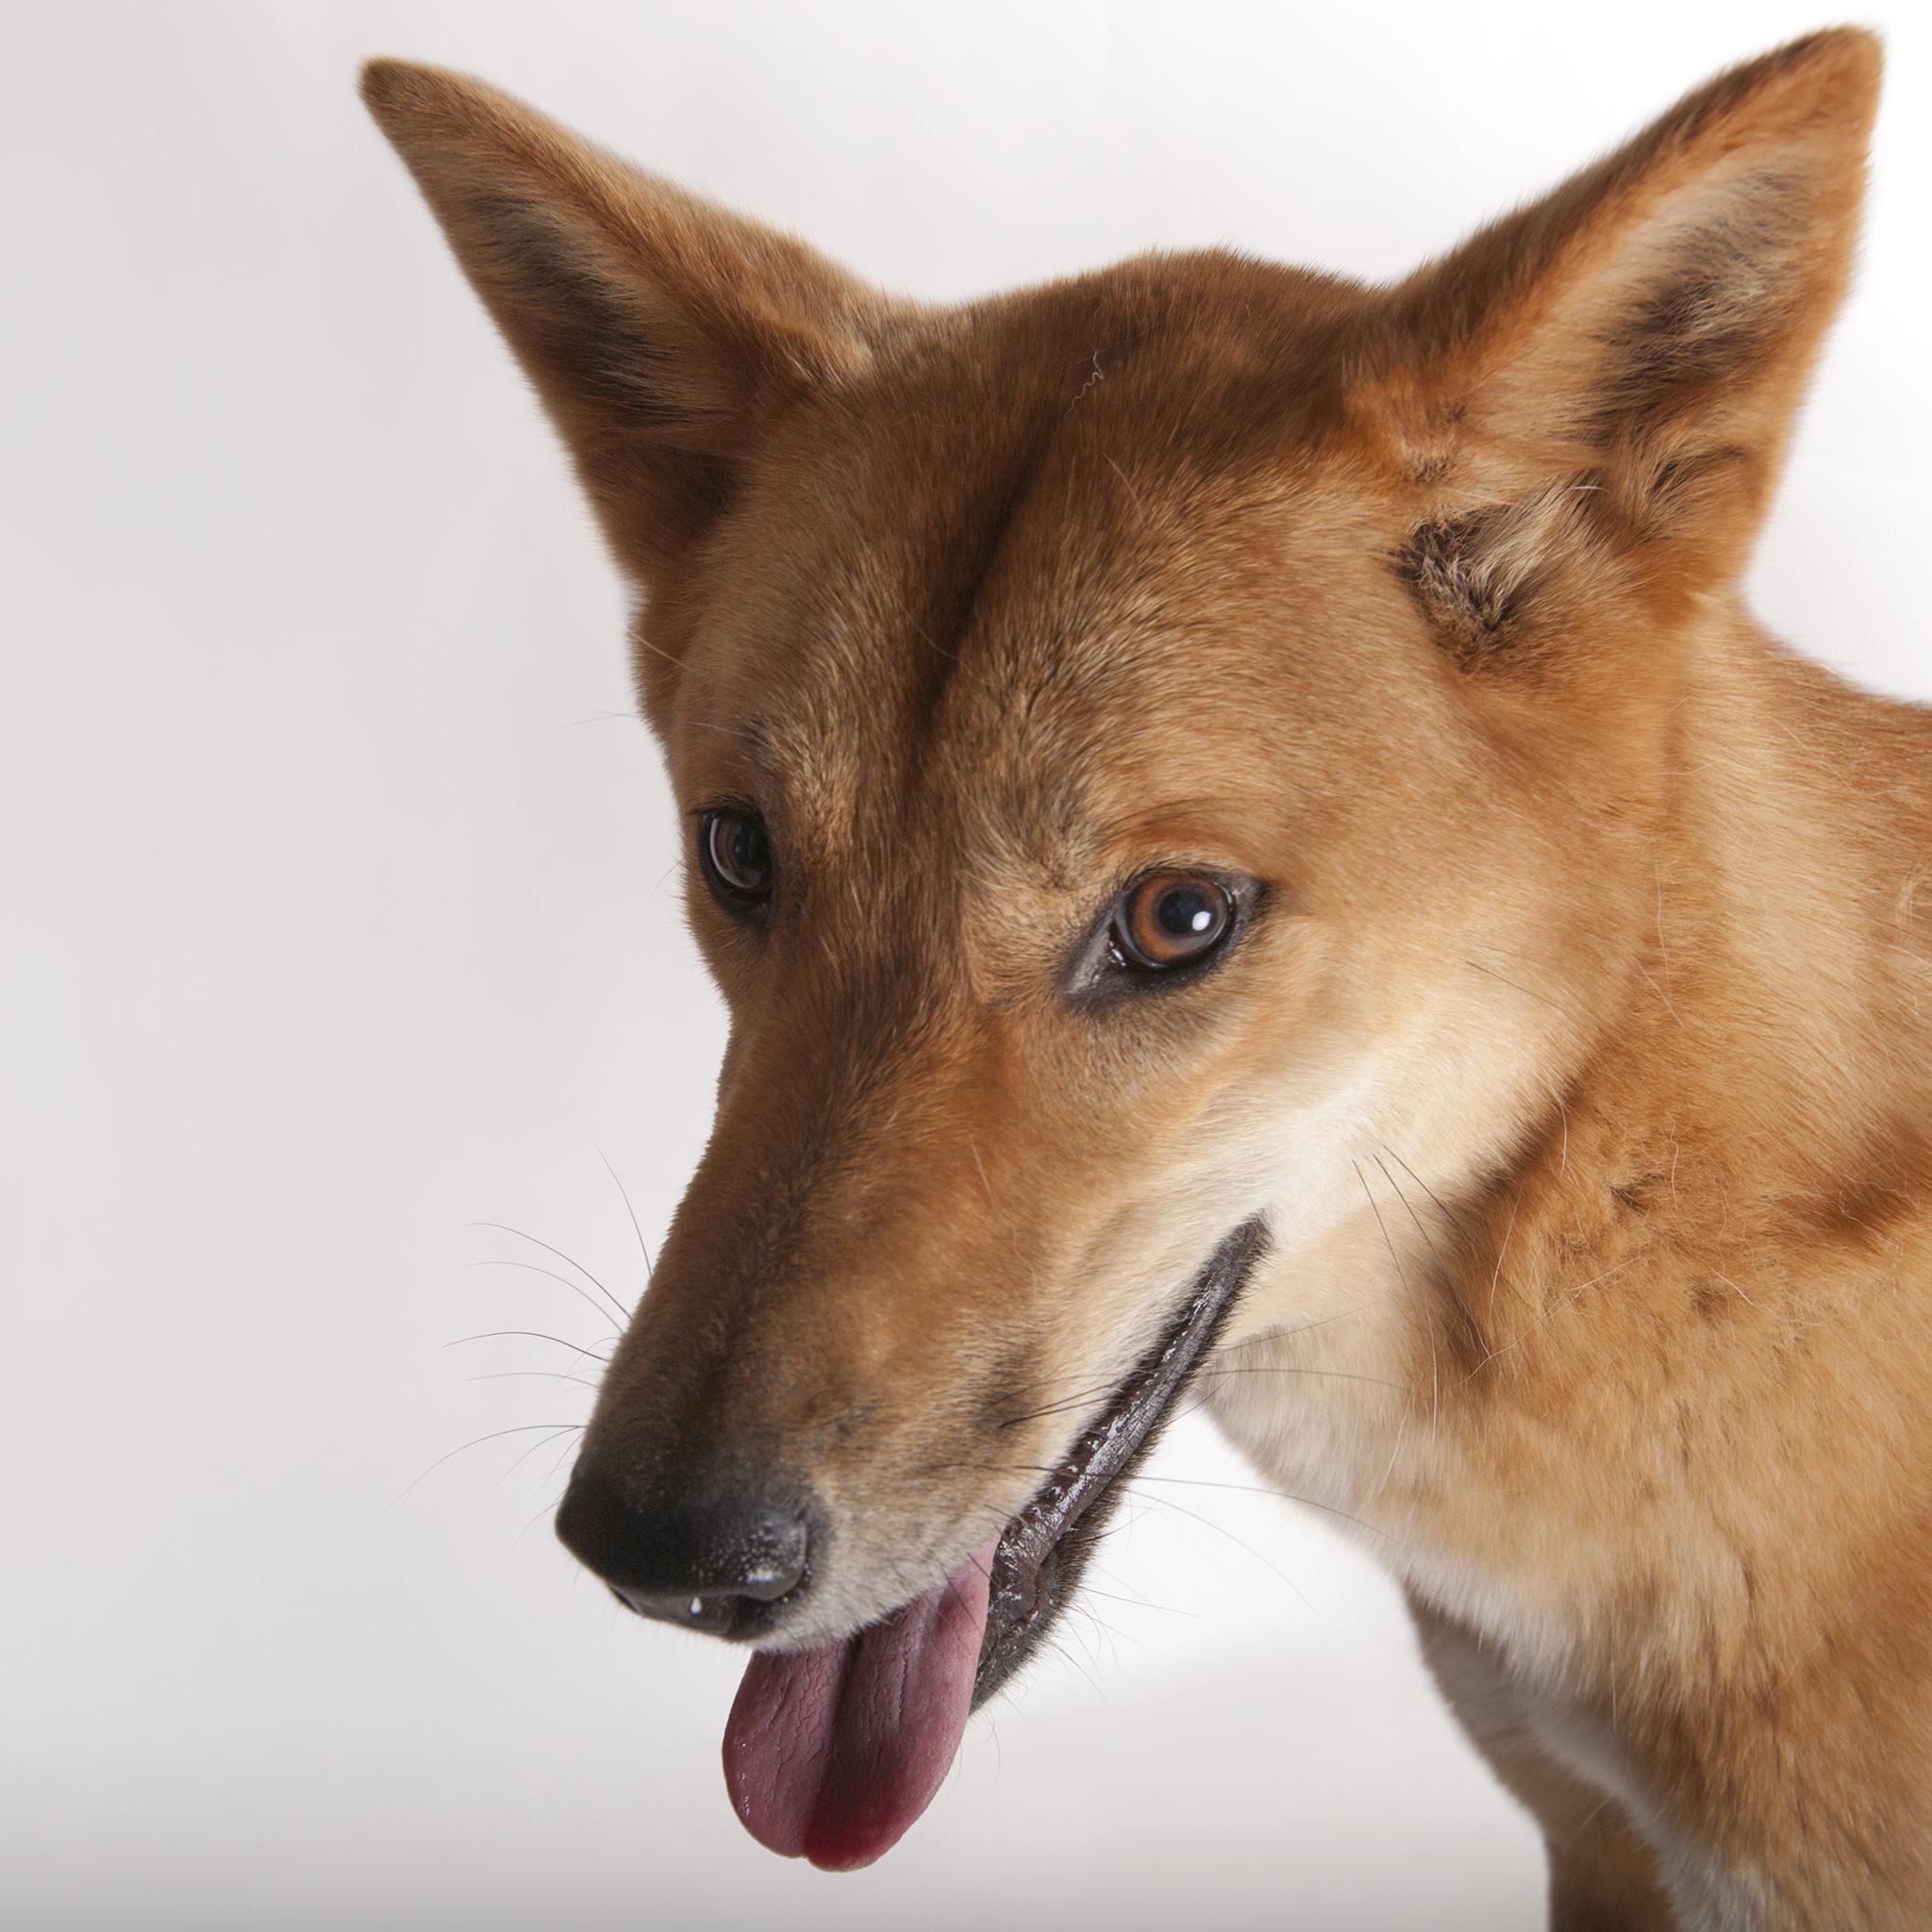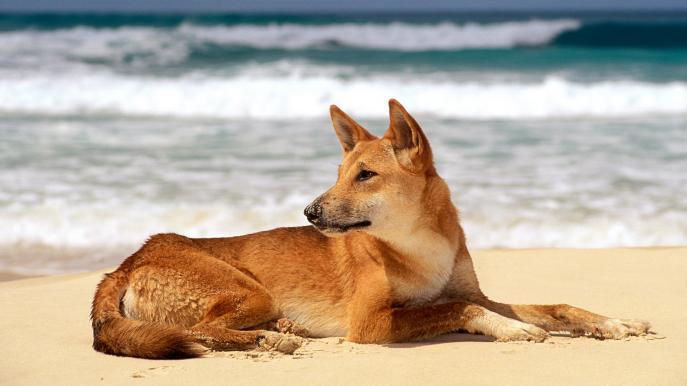The first image is the image on the left, the second image is the image on the right. Considering the images on both sides, is "Two wild dogs are lying outside in the image on the left." valid? Answer yes or no. No. The first image is the image on the left, the second image is the image on the right. Evaluate the accuracy of this statement regarding the images: "Two orange dogs are reclining in similar positions near one another.". Is it true? Answer yes or no. No. 